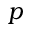Convert formula to latex. <formula><loc_0><loc_0><loc_500><loc_500>p</formula> 